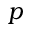Convert formula to latex. <formula><loc_0><loc_0><loc_500><loc_500>p</formula> 